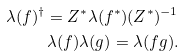<formula> <loc_0><loc_0><loc_500><loc_500>\lambda ( f ) ^ { \dagger } = Z ^ { * } \lambda ( f ^ { * } ) ( Z ^ { * } ) ^ { - 1 } \\ \lambda ( f ) \lambda ( g ) = \lambda ( f g ) .</formula> 